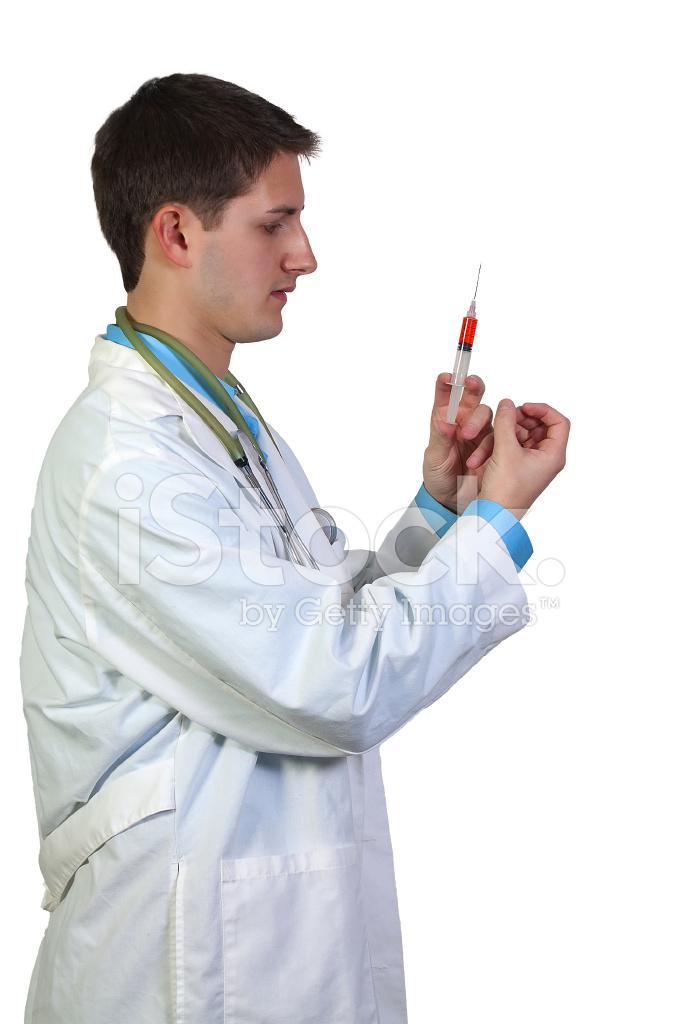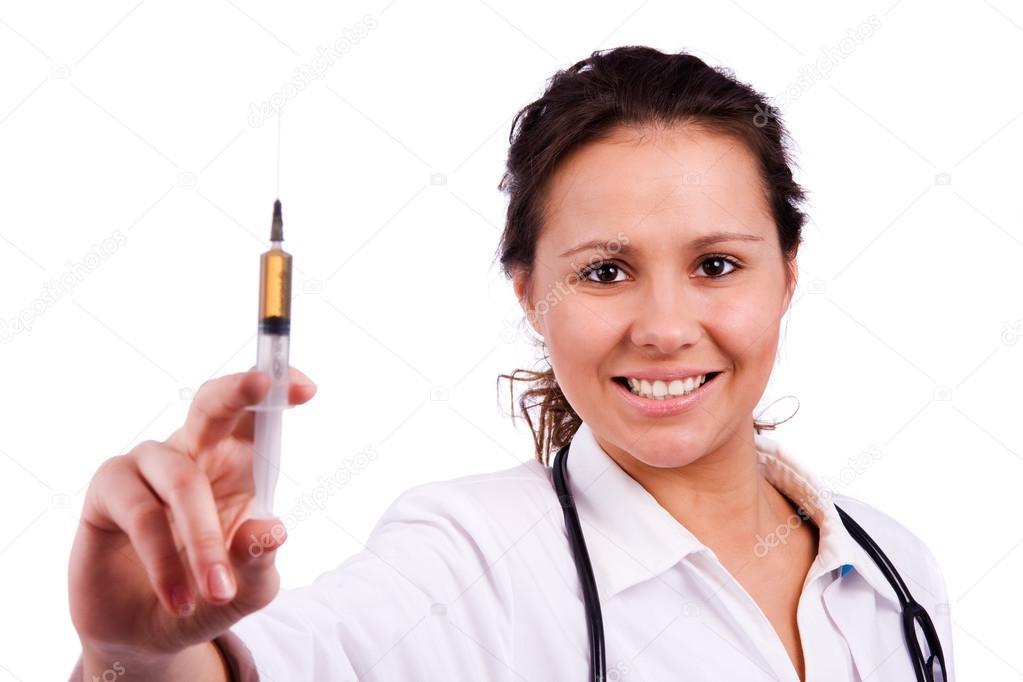The first image is the image on the left, the second image is the image on the right. Examine the images to the left and right. Is the description "The right image shows a forward-facing woman with a bare neck and white shirt holding up a syringe of yellow liquid." accurate? Answer yes or no. Yes. The first image is the image on the left, the second image is the image on the right. For the images shown, is this caption "The left and right image contains a total of two woman holding needles." true? Answer yes or no. No. 